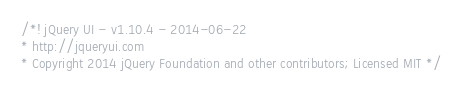<code> <loc_0><loc_0><loc_500><loc_500><_JavaScript_>/*! jQuery UI - v1.10.4 - 2014-06-22
* http://jqueryui.com
* Copyright 2014 jQuery Foundation and other contributors; Licensed MIT */
</code> 